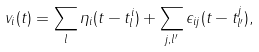<formula> <loc_0><loc_0><loc_500><loc_500>v _ { i } ( t ) = \sum _ { l } \eta _ { i } ( t - t _ { l } ^ { i } ) + \sum _ { j , l ^ { \prime } } \epsilon _ { i j } ( t - t _ { l ^ { \prime } } ^ { j } ) ,</formula> 